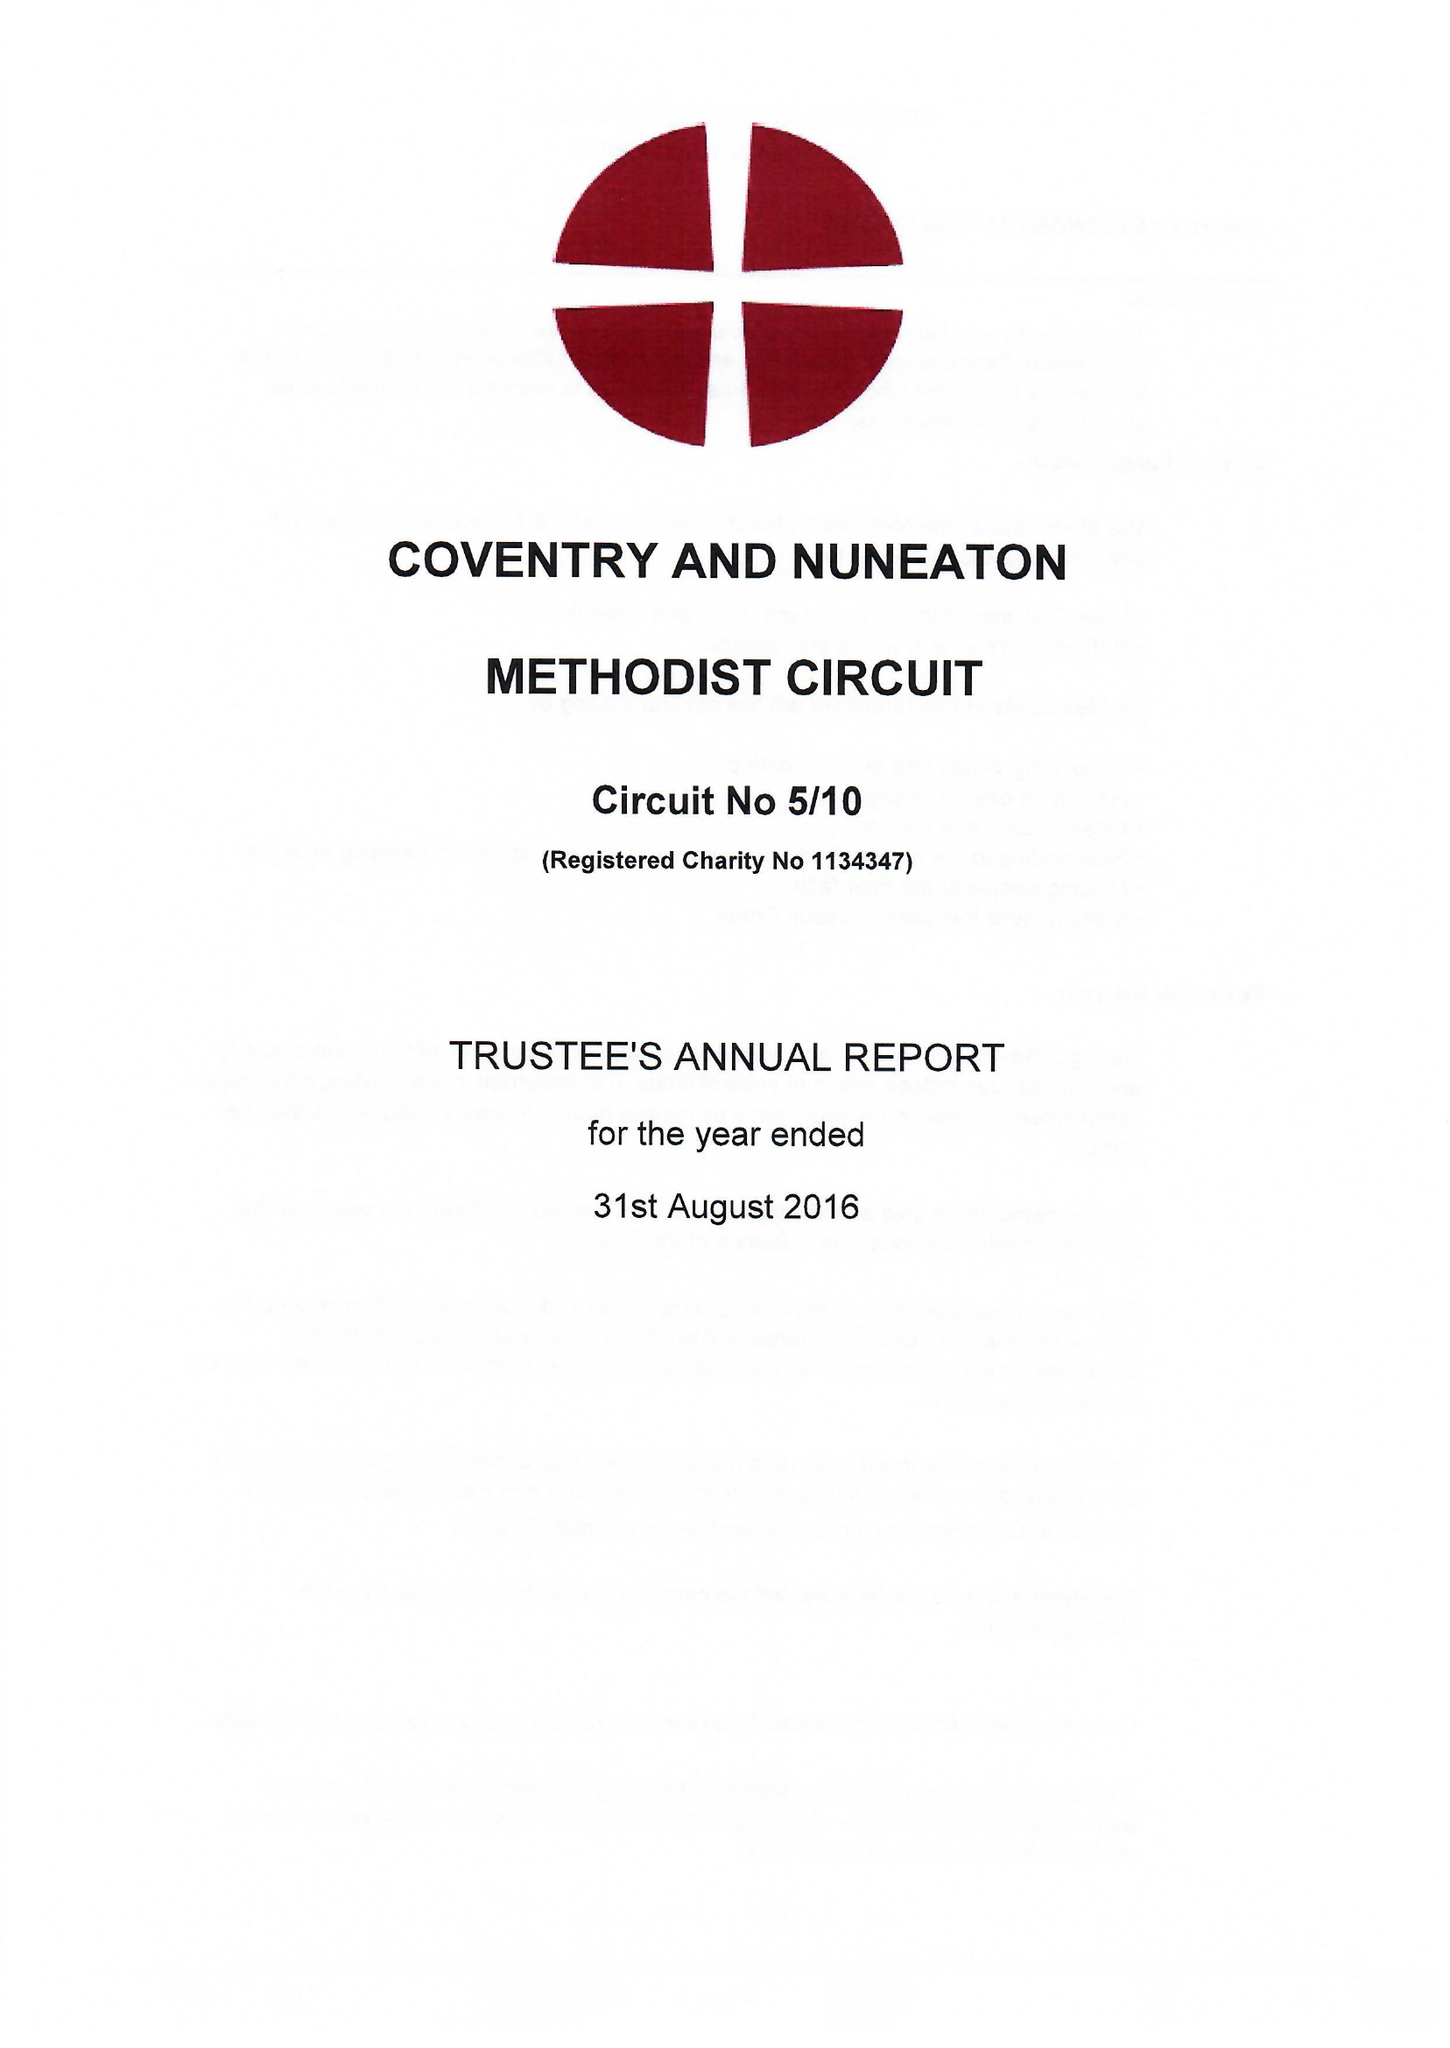What is the value for the charity_name?
Answer the question using a single word or phrase. Coventry and Nuneaton Methodist Circuit 